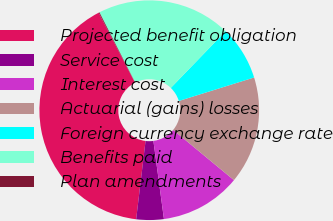Convert chart. <chart><loc_0><loc_0><loc_500><loc_500><pie_chart><fcel>Projected benefit obligation<fcel>Service cost<fcel>Interest cost<fcel>Actuarial (gains) losses<fcel>Foreign currency exchange rate<fcel>Benefits paid<fcel>Plan amendments<nl><fcel>40.48%<fcel>4.04%<fcel>11.88%<fcel>15.8%<fcel>7.96%<fcel>19.72%<fcel>0.12%<nl></chart> 